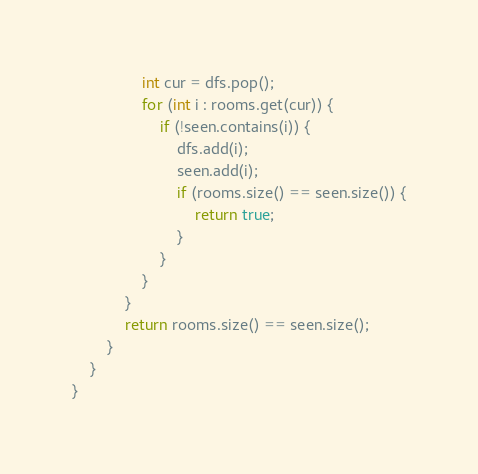<code> <loc_0><loc_0><loc_500><loc_500><_Java_>                int cur = dfs.pop();
                for (int i : rooms.get(cur)) {
                    if (!seen.contains(i)) {
                        dfs.add(i);
                        seen.add(i);
                        if (rooms.size() == seen.size()) {
                            return true;
                        }
                    }
                }
            }
            return rooms.size() == seen.size();
        }
    }
}
</code> 